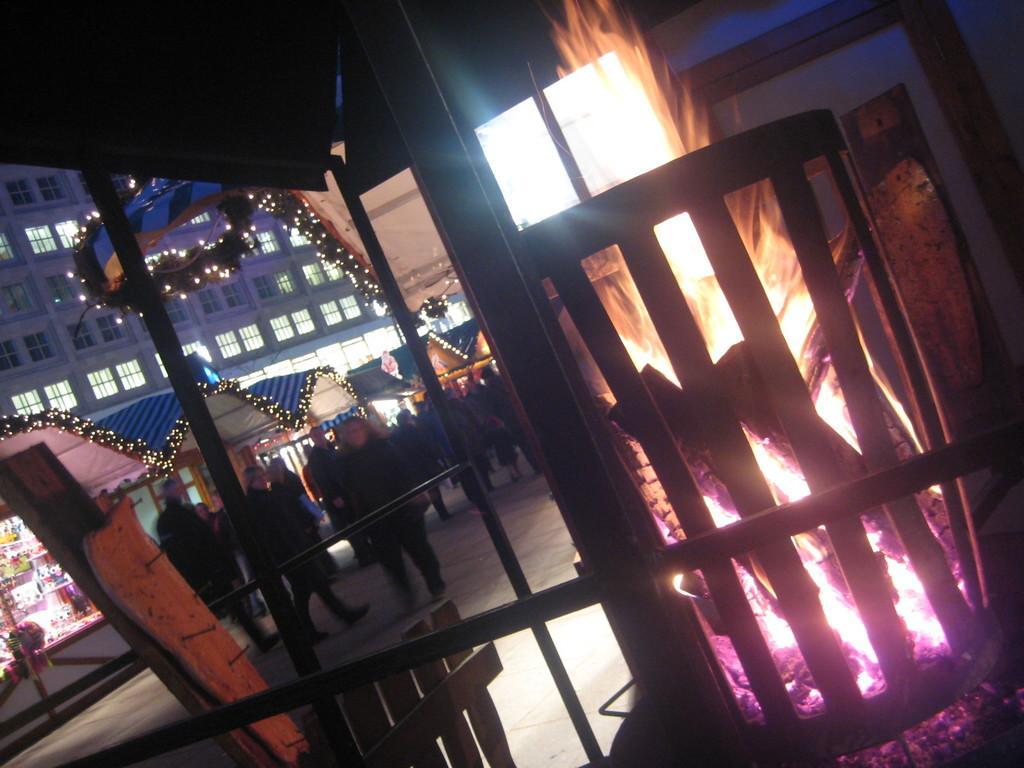Could you give a brief overview of what you see in this image? In this image on the left side there are group of people, and in the foreground there are some wooden sticks, fire, pole and some objects. And in the background there are buildings, lights and some objects. At the bottom there is a walkway. 